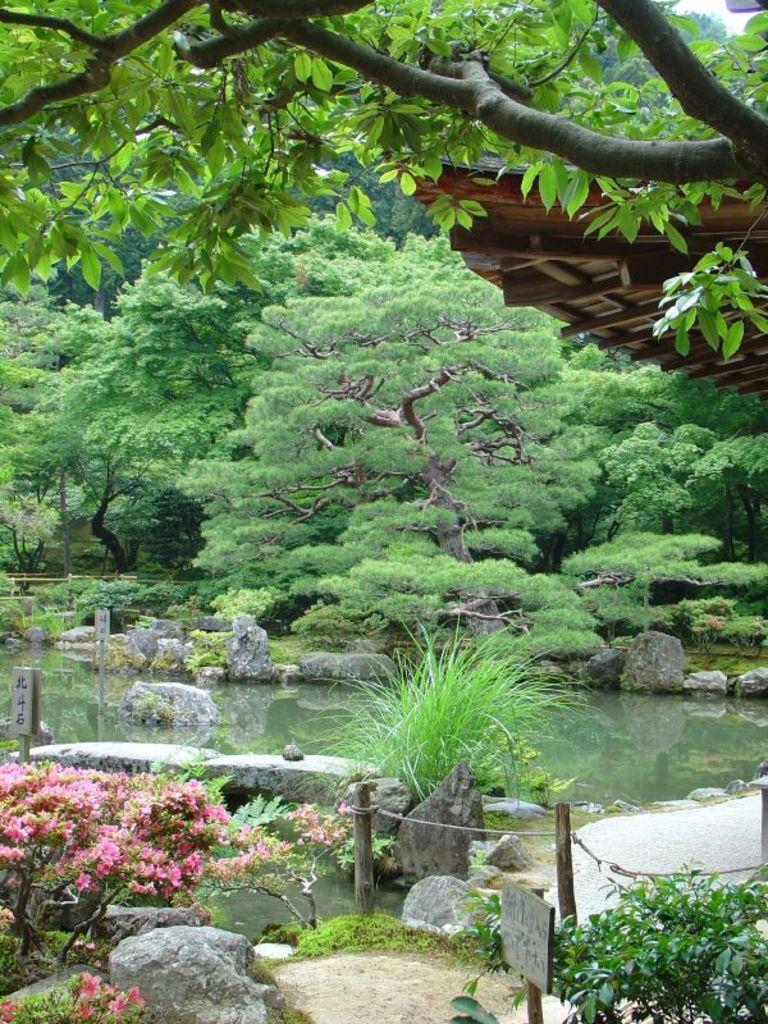What type of living organisms can be seen in the image? Plants, trees, and grass are visible in the image. What type of vegetation is present in the image? Trees and grass are present in the image. What architectural feature can be seen in the image? There is a railing in the image. What type of ground surface is visible in the image? Stones are visible in the image. What natural element is present in the image? Water is present in the image. Where are the flowers located in the image? The flowers are on the left side of the image. How many fingers are visible in the image? There are no fingers visible in the image. What type of army is depicted in the image? There is no army present in the image. 